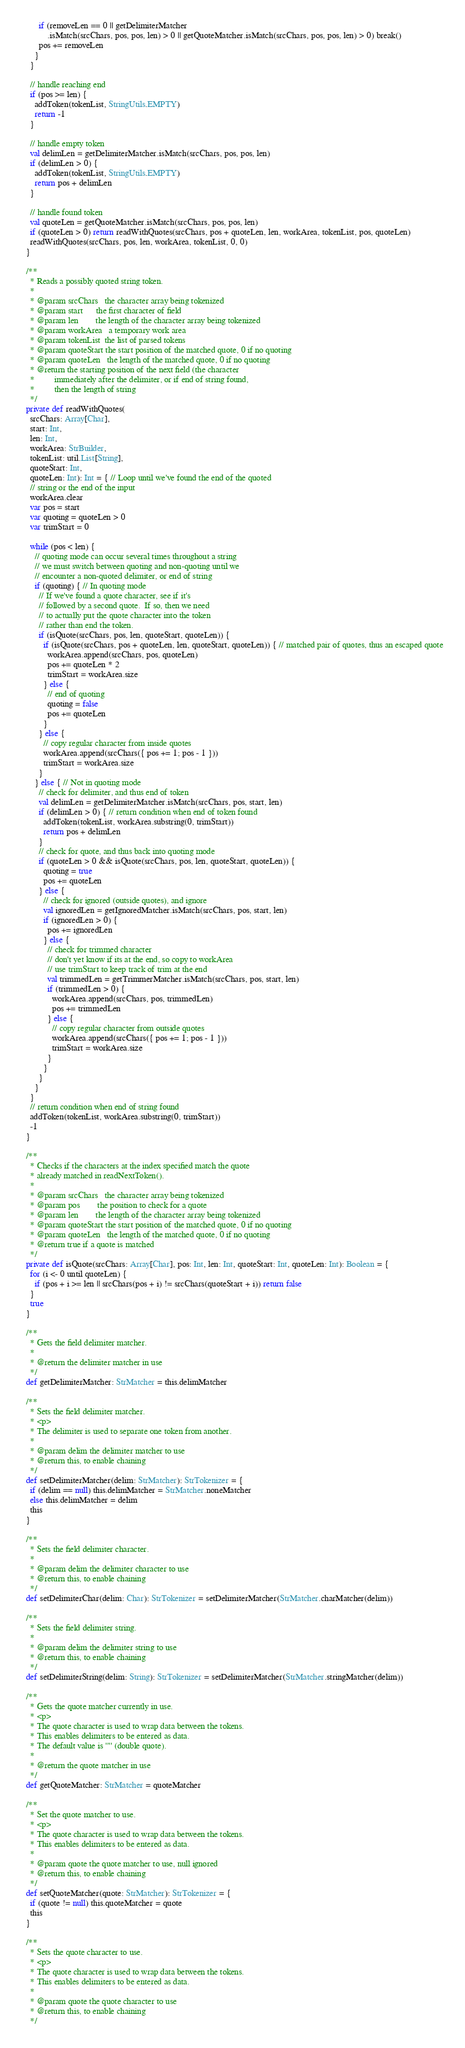Convert code to text. <code><loc_0><loc_0><loc_500><loc_500><_Scala_>        if (removeLen == 0 || getDelimiterMatcher
            .isMatch(srcChars, pos, pos, len) > 0 || getQuoteMatcher.isMatch(srcChars, pos, pos, len) > 0) break()
        pos += removeLen
      }
    }

    // handle reaching end
    if (pos >= len) {
      addToken(tokenList, StringUtils.EMPTY)
      return -1
    }

    // handle empty token
    val delimLen = getDelimiterMatcher.isMatch(srcChars, pos, pos, len)
    if (delimLen > 0) {
      addToken(tokenList, StringUtils.EMPTY)
      return pos + delimLen
    }

    // handle found token
    val quoteLen = getQuoteMatcher.isMatch(srcChars, pos, pos, len)
    if (quoteLen > 0) return readWithQuotes(srcChars, pos + quoteLen, len, workArea, tokenList, pos, quoteLen)
    readWithQuotes(srcChars, pos, len, workArea, tokenList, 0, 0)
  }

  /**
    * Reads a possibly quoted string token.
    *
    * @param srcChars   the character array being tokenized
    * @param start      the first character of field
    * @param len        the length of the character array being tokenized
    * @param workArea   a temporary work area
    * @param tokenList  the list of parsed tokens
    * @param quoteStart the start position of the matched quote, 0 if no quoting
    * @param quoteLen   the length of the matched quote, 0 if no quoting
    * @return the starting position of the next field (the character
    *         immediately after the delimiter, or if end of string found,
    *         then the length of string
    */
  private def readWithQuotes(
    srcChars: Array[Char],
    start: Int,
    len: Int,
    workArea: StrBuilder,
    tokenList: util.List[String],
    quoteStart: Int,
    quoteLen: Int): Int = { // Loop until we've found the end of the quoted
    // string or the end of the input
    workArea.clear
    var pos = start
    var quoting = quoteLen > 0
    var trimStart = 0

    while (pos < len) {
      // quoting mode can occur several times throughout a string
      // we must switch between quoting and non-quoting until we
      // encounter a non-quoted delimiter, or end of string
      if (quoting) { // In quoting mode
        // If we've found a quote character, see if it's
        // followed by a second quote.  If so, then we need
        // to actually put the quote character into the token
        // rather than end the token.
        if (isQuote(srcChars, pos, len, quoteStart, quoteLen)) {
          if (isQuote(srcChars, pos + quoteLen, len, quoteStart, quoteLen)) { // matched pair of quotes, thus an escaped quote
            workArea.append(srcChars, pos, quoteLen)
            pos += quoteLen * 2
            trimStart = workArea.size
          } else {
            // end of quoting
            quoting = false
            pos += quoteLen
          }
        } else {
          // copy regular character from inside quotes
          workArea.append(srcChars({ pos += 1; pos - 1 }))
          trimStart = workArea.size
        }
      } else { // Not in quoting mode
        // check for delimiter, and thus end of token
        val delimLen = getDelimiterMatcher.isMatch(srcChars, pos, start, len)
        if (delimLen > 0) { // return condition when end of token found
          addToken(tokenList, workArea.substring(0, trimStart))
          return pos + delimLen
        }
        // check for quote, and thus back into quoting mode
        if (quoteLen > 0 && isQuote(srcChars, pos, len, quoteStart, quoteLen)) {
          quoting = true
          pos += quoteLen
        } else {
          // check for ignored (outside quotes), and ignore
          val ignoredLen = getIgnoredMatcher.isMatch(srcChars, pos, start, len)
          if (ignoredLen > 0) {
            pos += ignoredLen
          } else {
            // check for trimmed character
            // don't yet know if its at the end, so copy to workArea
            // use trimStart to keep track of trim at the end
            val trimmedLen = getTrimmerMatcher.isMatch(srcChars, pos, start, len)
            if (trimmedLen > 0) {
              workArea.append(srcChars, pos, trimmedLen)
              pos += trimmedLen
            } else {
              // copy regular character from outside quotes
              workArea.append(srcChars({ pos += 1; pos - 1 }))
              trimStart = workArea.size
            }
          }
        }
      }
    }
    // return condition when end of string found
    addToken(tokenList, workArea.substring(0, trimStart))
    -1
  }

  /**
    * Checks if the characters at the index specified match the quote
    * already matched in readNextToken().
    *
    * @param srcChars   the character array being tokenized
    * @param pos        the position to check for a quote
    * @param len        the length of the character array being tokenized
    * @param quoteStart the start position of the matched quote, 0 if no quoting
    * @param quoteLen   the length of the matched quote, 0 if no quoting
    * @return true if a quote is matched
    */
  private def isQuote(srcChars: Array[Char], pos: Int, len: Int, quoteStart: Int, quoteLen: Int): Boolean = {
    for (i <- 0 until quoteLen) {
      if (pos + i >= len || srcChars(pos + i) != srcChars(quoteStart + i)) return false
    }
    true
  }

  /**
    * Gets the field delimiter matcher.
    *
    * @return the delimiter matcher in use
    */
  def getDelimiterMatcher: StrMatcher = this.delimMatcher

  /**
    * Sets the field delimiter matcher.
    * <p>
    * The delimiter is used to separate one token from another.
    *
    * @param delim the delimiter matcher to use
    * @return this, to enable chaining
    */
  def setDelimiterMatcher(delim: StrMatcher): StrTokenizer = {
    if (delim == null) this.delimMatcher = StrMatcher.noneMatcher
    else this.delimMatcher = delim
    this
  }

  /**
    * Sets the field delimiter character.
    *
    * @param delim the delimiter character to use
    * @return this, to enable chaining
    */
  def setDelimiterChar(delim: Char): StrTokenizer = setDelimiterMatcher(StrMatcher.charMatcher(delim))

  /**
    * Sets the field delimiter string.
    *
    * @param delim the delimiter string to use
    * @return this, to enable chaining
    */
  def setDelimiterString(delim: String): StrTokenizer = setDelimiterMatcher(StrMatcher.stringMatcher(delim))

  /**
    * Gets the quote matcher currently in use.
    * <p>
    * The quote character is used to wrap data between the tokens.
    * This enables delimiters to be entered as data.
    * The default value is '"' (double quote).
    *
    * @return the quote matcher in use
    */
  def getQuoteMatcher: StrMatcher = quoteMatcher

  /**
    * Set the quote matcher to use.
    * <p>
    * The quote character is used to wrap data between the tokens.
    * This enables delimiters to be entered as data.
    *
    * @param quote the quote matcher to use, null ignored
    * @return this, to enable chaining
    */
  def setQuoteMatcher(quote: StrMatcher): StrTokenizer = {
    if (quote != null) this.quoteMatcher = quote
    this
  }

  /**
    * Sets the quote character to use.
    * <p>
    * The quote character is used to wrap data between the tokens.
    * This enables delimiters to be entered as data.
    *
    * @param quote the quote character to use
    * @return this, to enable chaining
    */</code> 